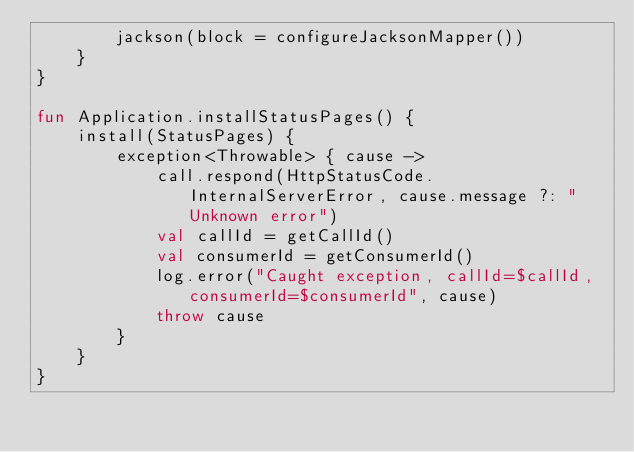<code> <loc_0><loc_0><loc_500><loc_500><_Kotlin_>        jackson(block = configureJacksonMapper())
    }
}

fun Application.installStatusPages() {
    install(StatusPages) {
        exception<Throwable> { cause ->
            call.respond(HttpStatusCode.InternalServerError, cause.message ?: "Unknown error")
            val callId = getCallId()
            val consumerId = getConsumerId()
            log.error("Caught exception, callId=$callId, consumerId=$consumerId", cause)
            throw cause
        }
    }
}
</code> 